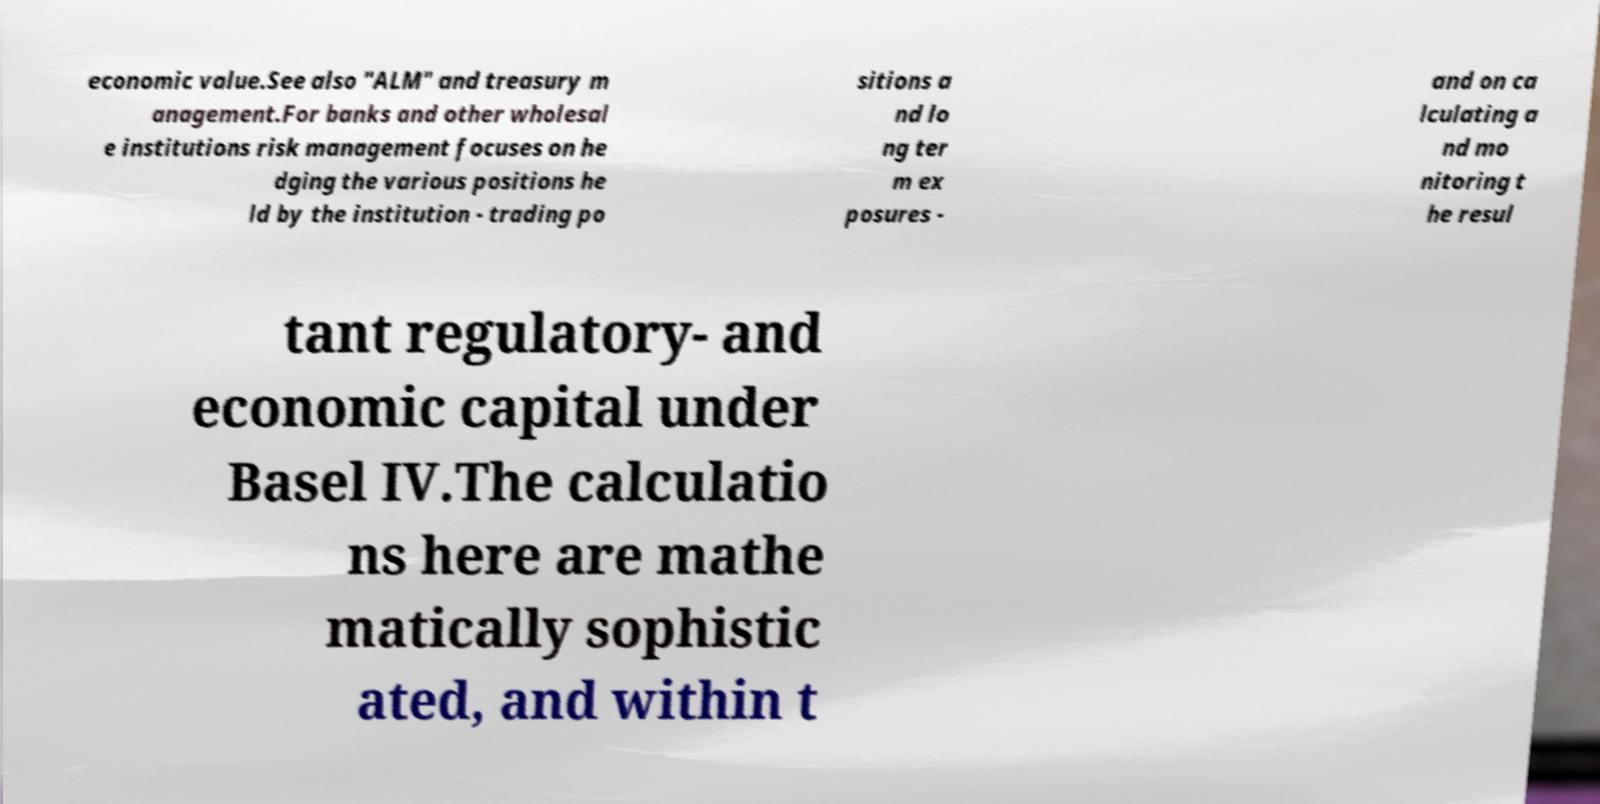Please identify and transcribe the text found in this image. economic value.See also "ALM" and treasury m anagement.For banks and other wholesal e institutions risk management focuses on he dging the various positions he ld by the institution - trading po sitions a nd lo ng ter m ex posures - and on ca lculating a nd mo nitoring t he resul tant regulatory- and economic capital under Basel IV.The calculatio ns here are mathe matically sophistic ated, and within t 